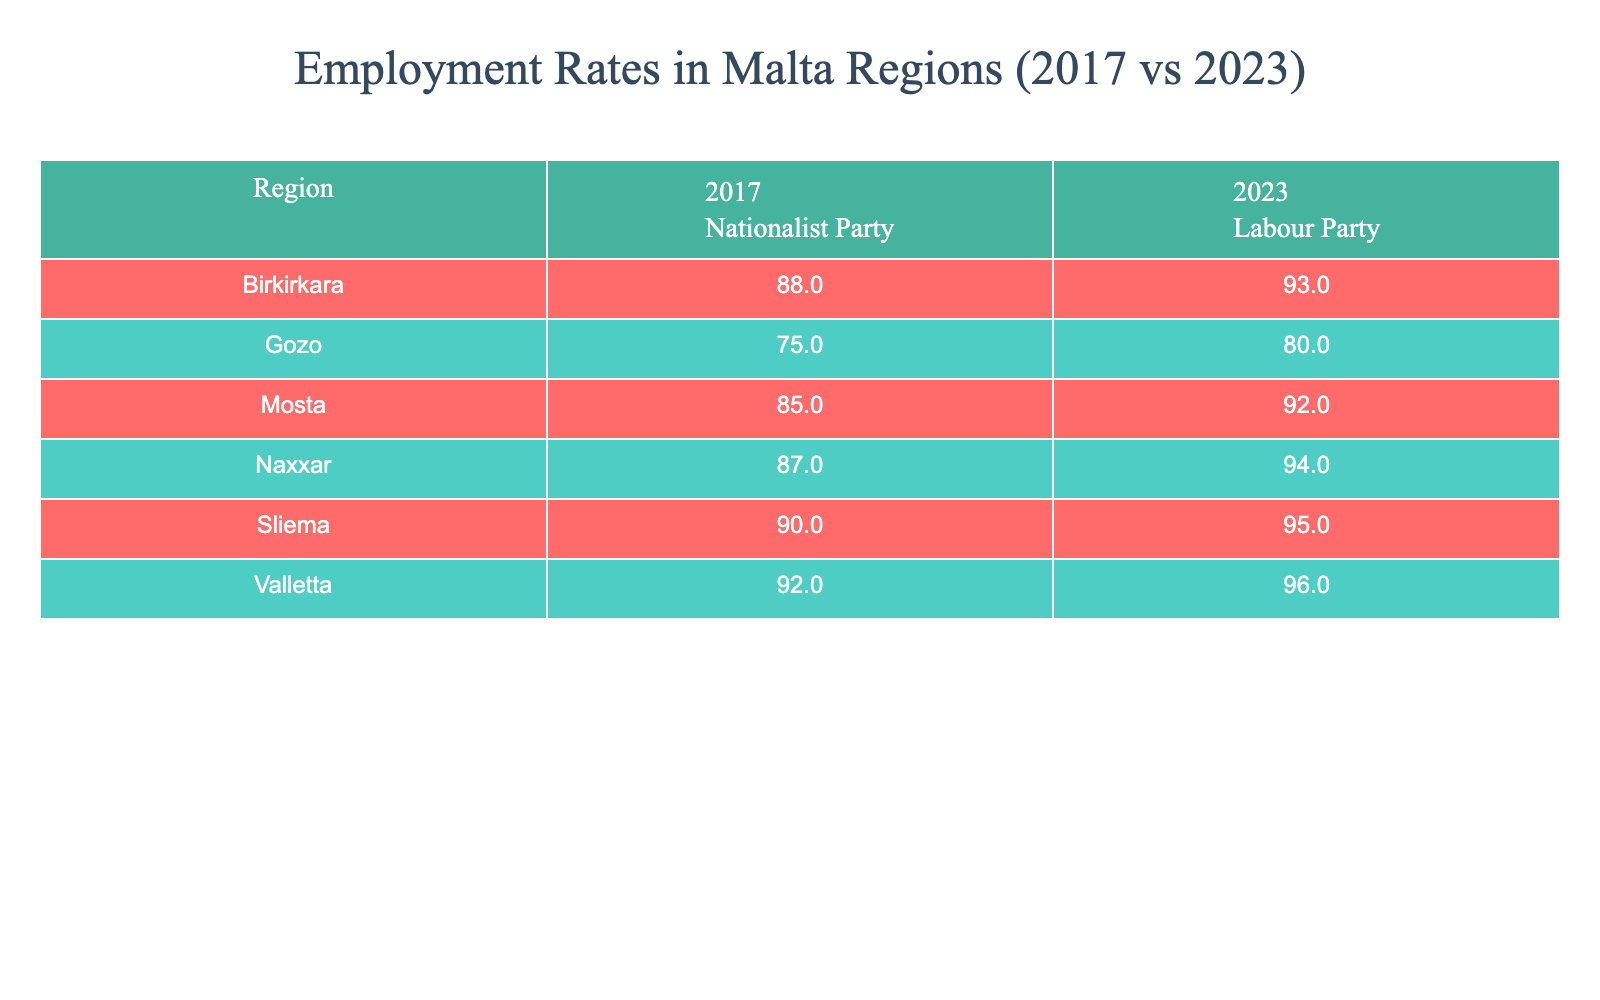What was the employment rate in Valletta in 2023? The table shows that the employment rate in Valletta for the year 2023 is 96%.
Answer: 96% What is the difference in employment rates for Mosta between 2017 and 2023? The employment rate in Mosta in 2017 was 85%, and in 2023 it rose to 92%. Therefore, the difference is 92% - 85% = 7%.
Answer: 7% Did the employment rate in Sliema improve from 2017 to 2023? In 2017, the employment rate in Sliema was 90%, and in 2023 it increased to 95%. Since 95% is greater than 90%, the employment rate improved.
Answer: Yes What is the average employment rate in Birkirkara across the two years? The employment rates in Birkirkara are 88% for 2017 and 93% for 2023. To find the average, we sum both rates: 88% + 93% = 181%. Dividing by 2 gives an average of 181% / 2 = 90.5%.
Answer: 90.5% Is Gozo's employment rate higher after Labor-led policies than in 2017? The employment rate in Gozo for 2017 was 75% and increased to 80% in 2023. Since 80% is greater than 75%, the employment rate in Gozo is higher after Labor-led policies.
Answer: Yes What is the employment rate difference between Naxxar in 2023 and Valletta in the same year? The employment rate in Naxxar in 2023 is 94%, and in Valletta, it is 96%. Therefore, the difference is 96% - 94% = 2%.
Answer: 2% Which region saw the greatest increase in employment rate from 2017 to 2023? By examining the increases for each region: Valletta (4%), Sliema (5%), Birkirkara (5%), Mosta (7%), Naxxar (7%), and Gozo (5%), the maximum increase is 7% for Mosta and Naxxar. Hence, both regions had the greatest identical increase.
Answer: Mosta and Naxxar (7%) In which year did Birkirkara have a higher employment rate? In 2017, Birkirkara had an employment rate of 88%, while in 2023, it increased to 93%. Therefore, 2023 had a higher employment rate compared to 2017.
Answer: 2023 What was the overall employment trend across all regions from 2017 to 2023? To understand the overall trend, we analyze the changes: Valletta improved by 4%, Sliema by 5%, Birkirkara by 5%, Mosta by 7%, Naxxar by 7%, and Gozo by 5%. All regions showed positive growth in employment rates from 2017 to 2023, indicating an overall upward trend.
Answer: Upward trend 